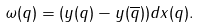<formula> <loc_0><loc_0><loc_500><loc_500>\omega ( q ) = ( y ( q ) - y ( \overline { q } ) ) d x ( q ) .</formula> 